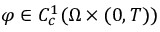Convert formula to latex. <formula><loc_0><loc_0><loc_500><loc_500>\varphi \in C _ { c } ^ { 1 } ( \Omega \times ( 0 , T ) )</formula> 